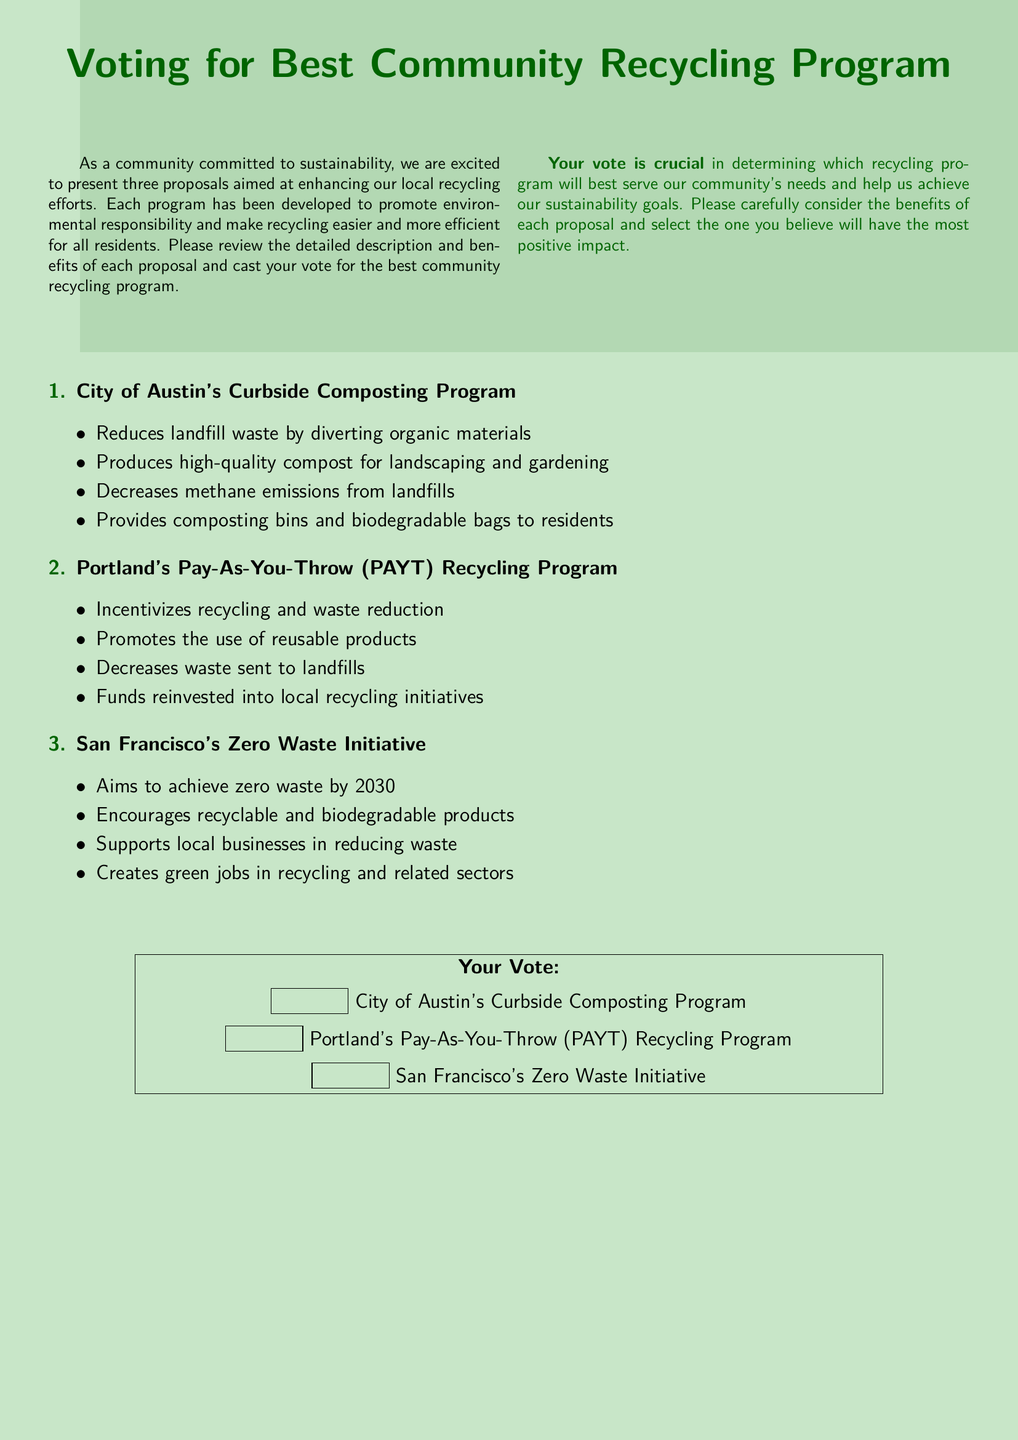What is the title of the document? The title of the document is prominently displayed at the top and is used to introduce the subject of the ballot.
Answer: Voting for Best Community Recycling Program How many proposals are presented in the document? The document outlines three distinct proposals aimed at enhancing community recycling efforts.
Answer: Three What program aims to achieve zero waste by 2030? This program specifically targets zero waste and emphasizes sustainability in its objectives.
Answer: San Francisco's Zero Waste Initiative Which program provides composting bins to residents? The proposal description includes specific provisions for residents, highlighting its practical support.
Answer: City of Austin's Curbside Composting Program What is one benefit of Portland's PAYT Recycling Program? The benefit relates to incentivizing community behavior regarding waste management and recycling practices.
Answer: Incentivizes recycling and waste reduction Which program supports local businesses in reducing waste? This aspect of the proposal focuses on partnerships with businesses to promote sustainability.
Answer: San Francisco's Zero Waste Initiative What color is used for the document's background? The background color is chosen to reflect environmental themes and is consistently applied throughout the document.
Answer: Light green Where do residents cast their votes? The location for casting votes is indicated in the structure and layout of the document with a designated area.
Answer: In the voting section at the bottom 